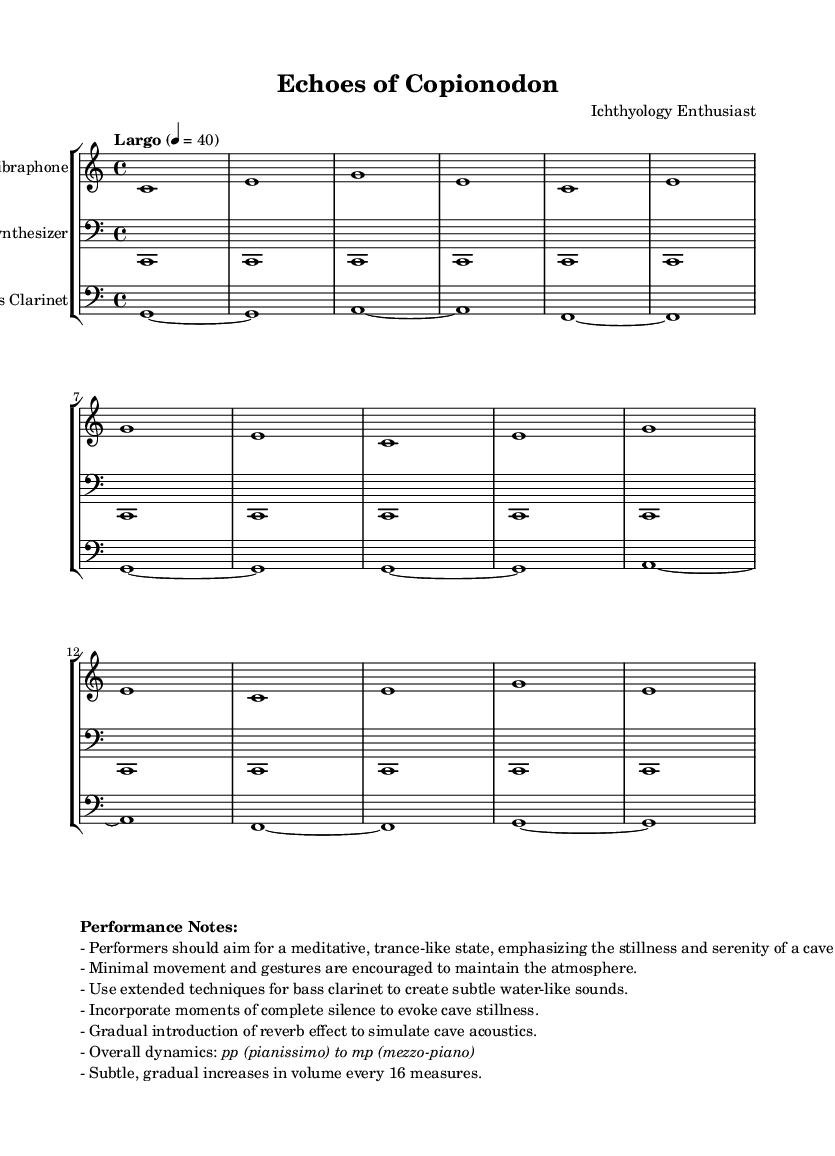What is the time signature of this music? The time signature shown in the music is indicated at the beginning, where it specifies 4/4. This means there are four beats in each measure.
Answer: 4/4 What is the tempo of the piece? The tempo marking in the music indicates "Largo" with a metronome marking of 4 = 40. This indicates a slow tempo, typically characterized by a relaxed pace.
Answer: Largo 4 = 40 How many measures does the vibraphone part repeat? The vibraphone part indicates a repeat of "unfold 4," meaning the section is played four times, staying true to the minimalist style.
Answer: 4 What extended techniques are suggested for the bass clarinet? The performance notes specifically mention using extended techniques to create subtle water-like sounds, enhancing the atmosphere of the piece.
Answer: Water-like sounds What overall dynamics are indicated for the piece? The performance notes detail that dynamics should range from pianissimo to mezzo-piano, indicating a very soft to moderately soft sound throughout the performance.
Answer: pp to mp What effect is suggested for the synthesizer part? The performance notes recommend introducing a gradual reverb effect, which simulates the acoustics of a cave, adding depth and echo to the sound.
Answer: Reverb effect 